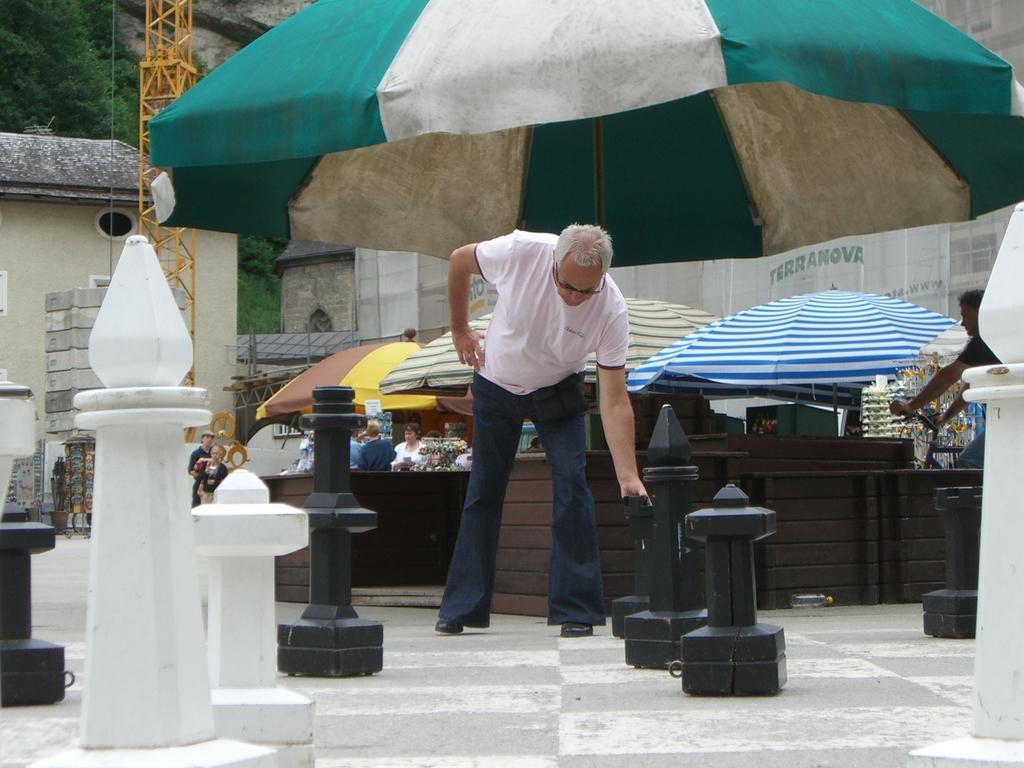Describe this image in one or two sentences. In this image we can see few objects looks like pillars, a person is holding the pillar, in the background there are few stalls with umbrellas and a person is riding a bicycle, there are buildings and trees. 